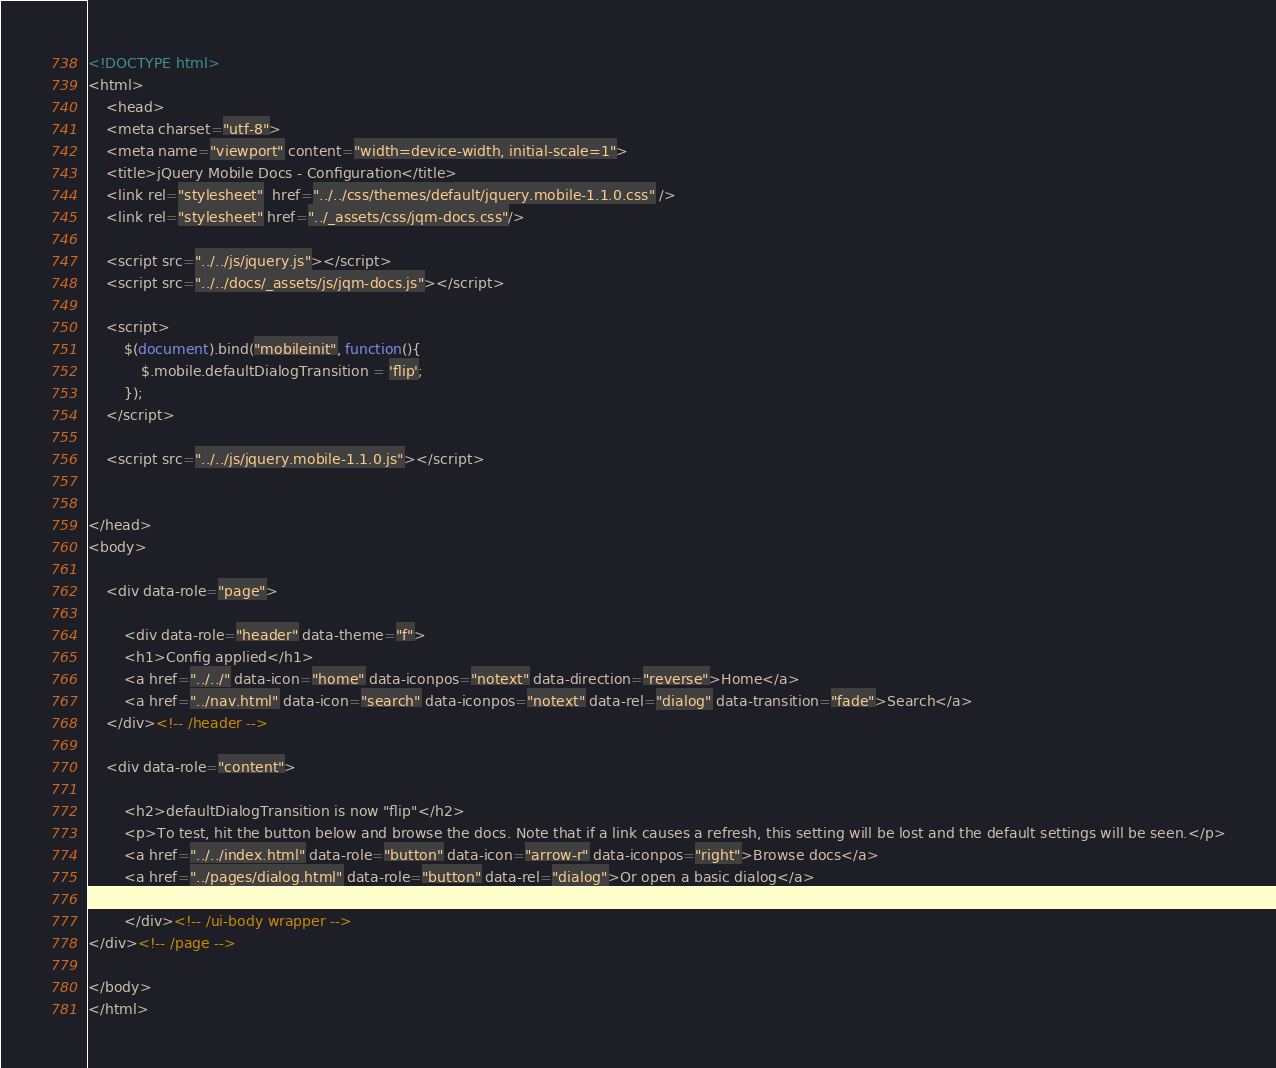Convert code to text. <code><loc_0><loc_0><loc_500><loc_500><_HTML_><!DOCTYPE html> 
<html>
	<head>
	<meta charset="utf-8">
	<meta name="viewport" content="width=device-width, initial-scale=1"> 
	<title>jQuery Mobile Docs - Configuration</title> 
	<link rel="stylesheet"  href="../../css/themes/default/jquery.mobile-1.1.0.css" />  
	<link rel="stylesheet" href="../_assets/css/jqm-docs.css"/>

	<script src="../../js/jquery.js"></script>
	<script src="../../docs/_assets/js/jqm-docs.js"></script>

	<script>
		$(document).bind("mobileinit", function(){
			$.mobile.defaultDialogTransition = 'flip';
		});
	</script>
	
	<script src="../../js/jquery.mobile-1.1.0.js"></script>
	

</head> 
<body> 

	<div data-role="page">

		<div data-role="header" data-theme="f">
		<h1>Config applied</h1>
		<a href="../../" data-icon="home" data-iconpos="notext" data-direction="reverse">Home</a>
		<a href="../nav.html" data-icon="search" data-iconpos="notext" data-rel="dialog" data-transition="fade">Search</a>
	</div><!-- /header -->

	<div data-role="content">
		
		<h2>defaultDialogTransition is now "flip"</h2>
		<p>To test, hit the button below and browse the docs. Note that if a link causes a refresh, this setting will be lost and the default settings will be seen.</p>
		<a href="../../index.html" data-role="button" data-icon="arrow-r" data-iconpos="right">Browse docs</a>
		<a href="../pages/dialog.html" data-role="button" data-rel="dialog">Or open a basic dialog</a>

		</div><!-- /ui-body wrapper -->	
</div><!-- /page -->

</body>
</html>
</code> 